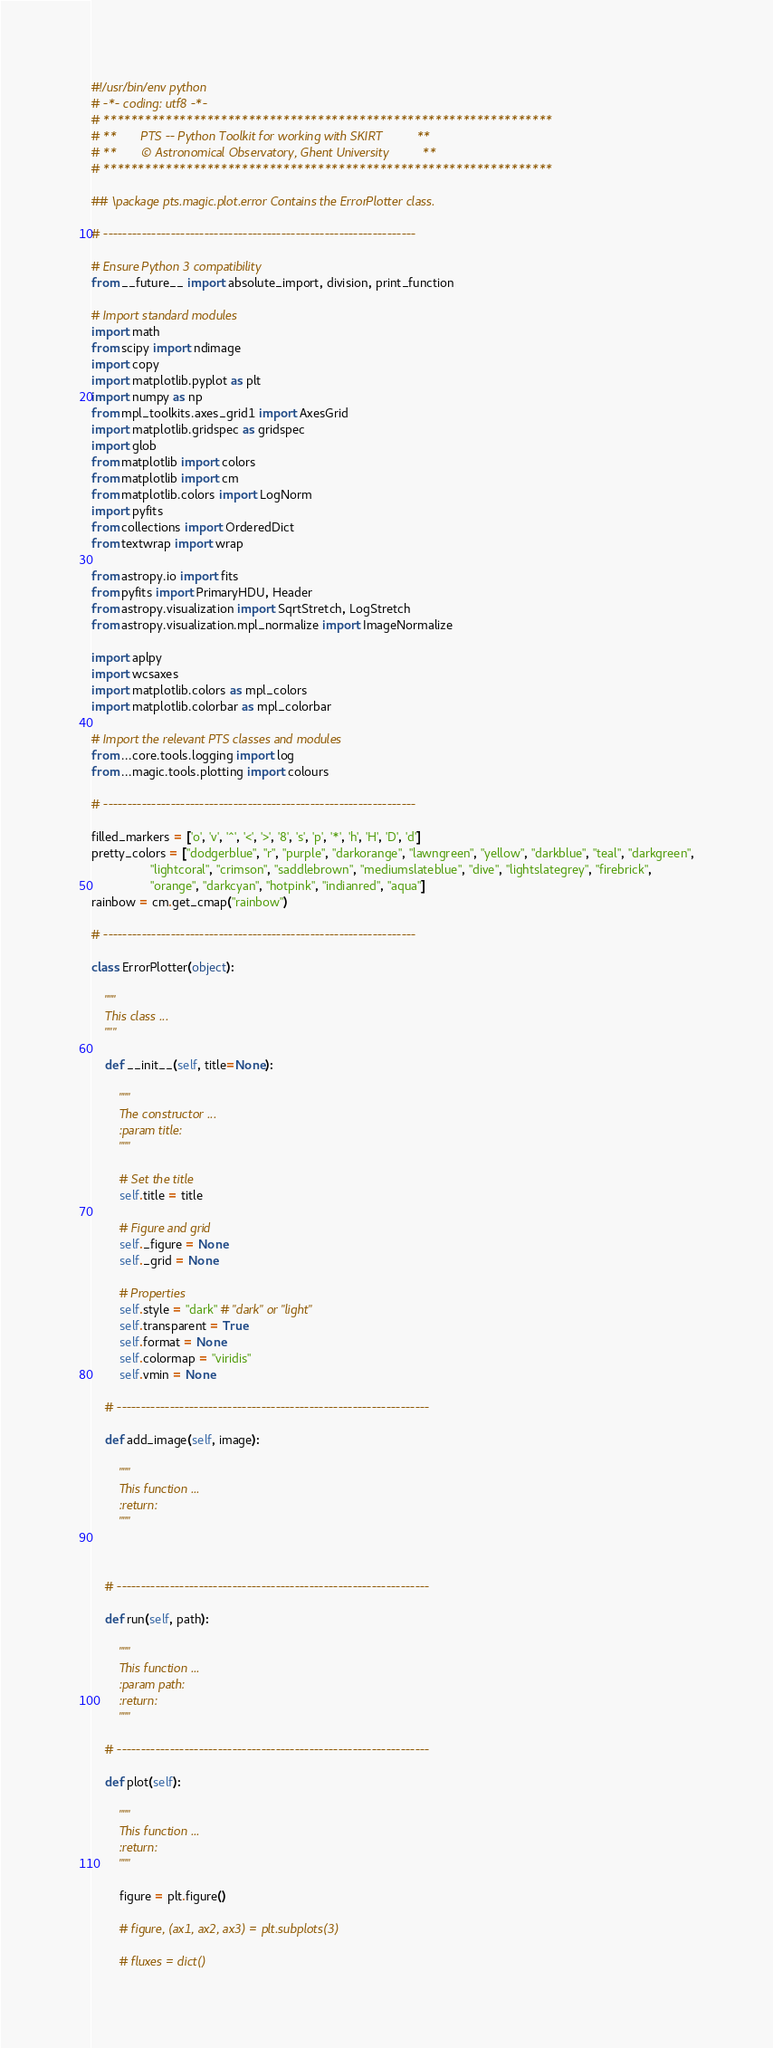<code> <loc_0><loc_0><loc_500><loc_500><_Python_>#!/usr/bin/env python
# -*- coding: utf8 -*-
# *****************************************************************
# **       PTS -- Python Toolkit for working with SKIRT          **
# **       © Astronomical Observatory, Ghent University          **
# *****************************************************************

## \package pts.magic.plot.error Contains the ErrorPlotter class.

# -----------------------------------------------------------------

# Ensure Python 3 compatibility
from __future__ import absolute_import, division, print_function

# Import standard modules
import math
from scipy import ndimage
import copy
import matplotlib.pyplot as plt
import numpy as np
from mpl_toolkits.axes_grid1 import AxesGrid
import matplotlib.gridspec as gridspec
import glob
from matplotlib import colors
from matplotlib import cm
from matplotlib.colors import LogNorm
import pyfits
from collections import OrderedDict
from textwrap import wrap

from astropy.io import fits
from pyfits import PrimaryHDU, Header
from astropy.visualization import SqrtStretch, LogStretch
from astropy.visualization.mpl_normalize import ImageNormalize

import aplpy
import wcsaxes
import matplotlib.colors as mpl_colors
import matplotlib.colorbar as mpl_colorbar

# Import the relevant PTS classes and modules
from ...core.tools.logging import log
from ...magic.tools.plotting import colours

# -----------------------------------------------------------------

filled_markers = ['o', 'v', '^', '<', '>', '8', 's', 'p', '*', 'h', 'H', 'D', 'd']
pretty_colors = ["dodgerblue", "r", "purple", "darkorange", "lawngreen", "yellow", "darkblue", "teal", "darkgreen",
                 "lightcoral", "crimson", "saddlebrown", "mediumslateblue", "dive", "lightslategrey", "firebrick",
                 "orange", "darkcyan", "hotpink", "indianred", "aqua"]
rainbow = cm.get_cmap("rainbow")

# -----------------------------------------------------------------

class ErrorPlotter(object):

    """
    This class ...
    """

    def __init__(self, title=None):

        """
        The constructor ...
        :param title:
        """

        # Set the title
        self.title = title

        # Figure and grid
        self._figure = None
        self._grid = None

        # Properties
        self.style = "dark" # "dark" or "light"
        self.transparent = True
        self.format = None
        self.colormap = "viridis"
        self.vmin = None

    # -----------------------------------------------------------------

    def add_image(self, image):

        """
        This function ...
        :return:
        """



    # -----------------------------------------------------------------

    def run(self, path):

        """
        This function ...
        :param path:
        :return:
        """

    # -----------------------------------------------------------------

    def plot(self):

        """
        This function ...
        :return:
        """

        figure = plt.figure()

        # figure, (ax1, ax2, ax3) = plt.subplots(3)

        # fluxes = dict()</code> 